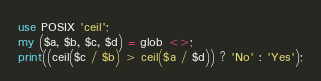<code> <loc_0><loc_0><loc_500><loc_500><_Perl_>use POSIX 'ceil';
my ($a, $b, $c, $d) = glob <>;
print((ceil($c / $b) > ceil($a / $d)) ? 'No' : 'Yes');</code> 